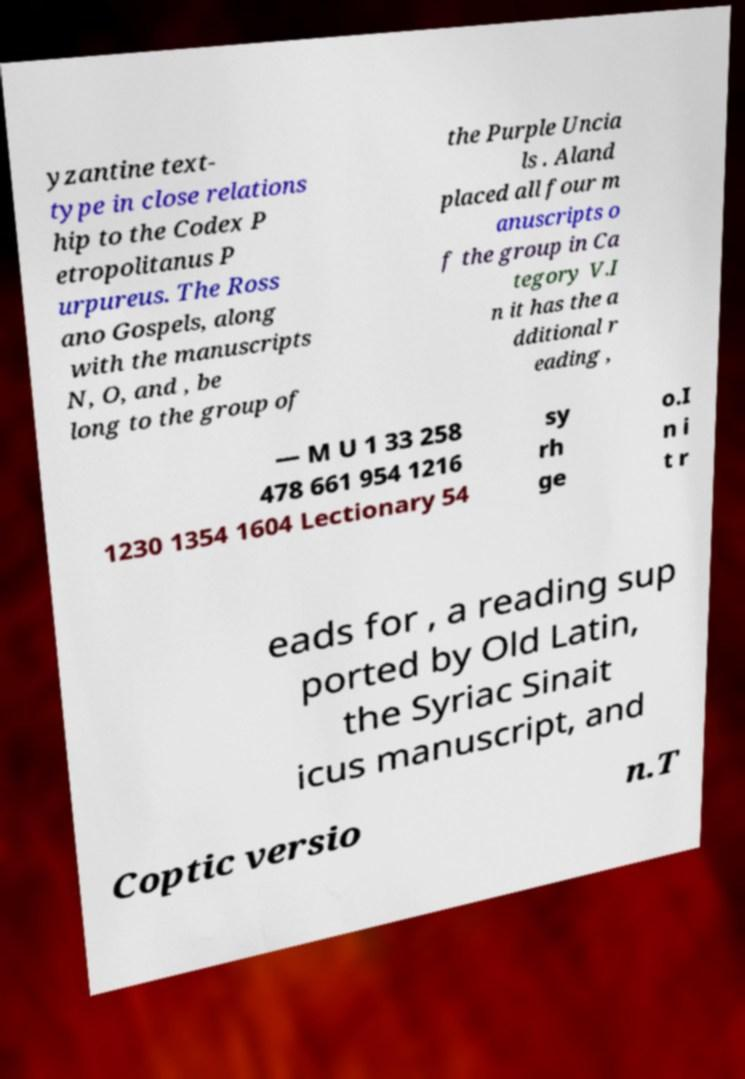Can you accurately transcribe the text from the provided image for me? yzantine text- type in close relations hip to the Codex P etropolitanus P urpureus. The Ross ano Gospels, along with the manuscripts N, O, and , be long to the group of the Purple Uncia ls . Aland placed all four m anuscripts o f the group in Ca tegory V.I n it has the a dditional r eading , — M U 1 33 258 478 661 954 1216 1230 1354 1604 Lectionary 54 sy rh ge o.I n i t r eads for , a reading sup ported by Old Latin, the Syriac Sinait icus manuscript, and Coptic versio n.T 